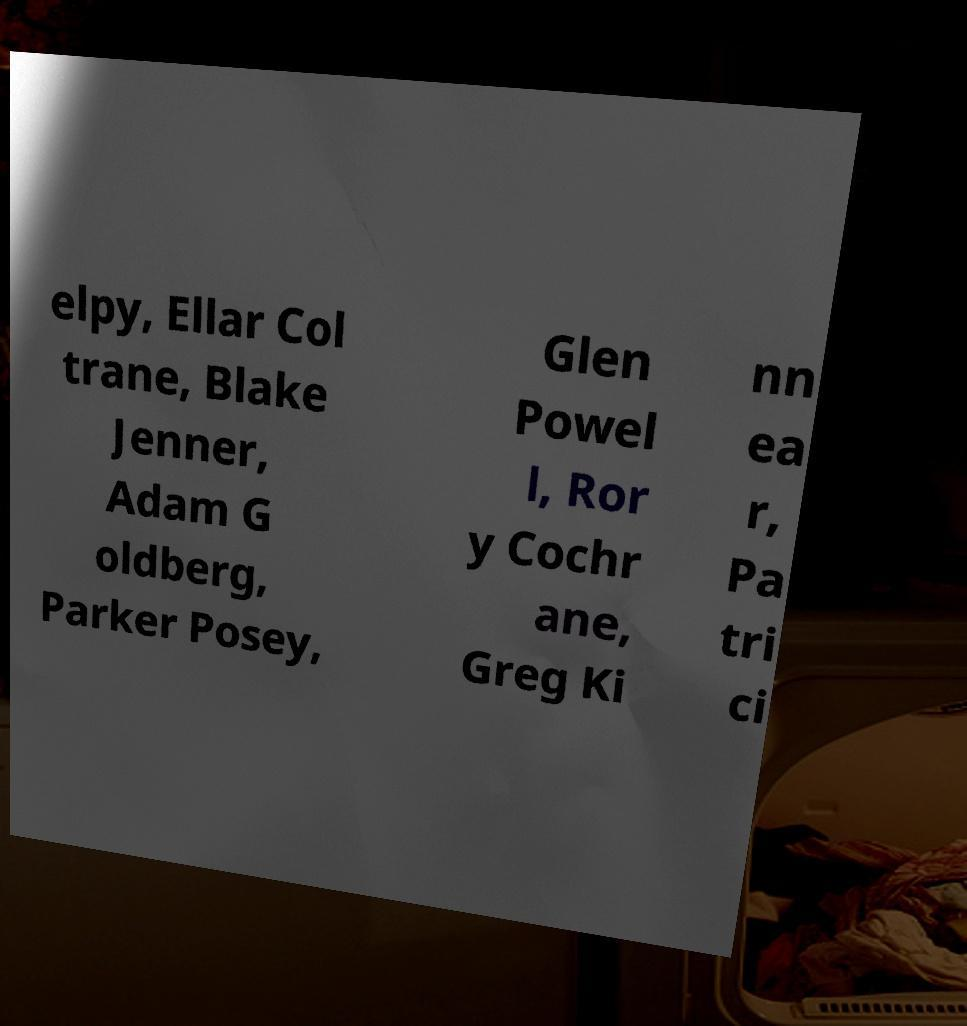Can you read and provide the text displayed in the image?This photo seems to have some interesting text. Can you extract and type it out for me? elpy, Ellar Col trane, Blake Jenner, Adam G oldberg, Parker Posey, Glen Powel l, Ror y Cochr ane, Greg Ki nn ea r, Pa tri ci 